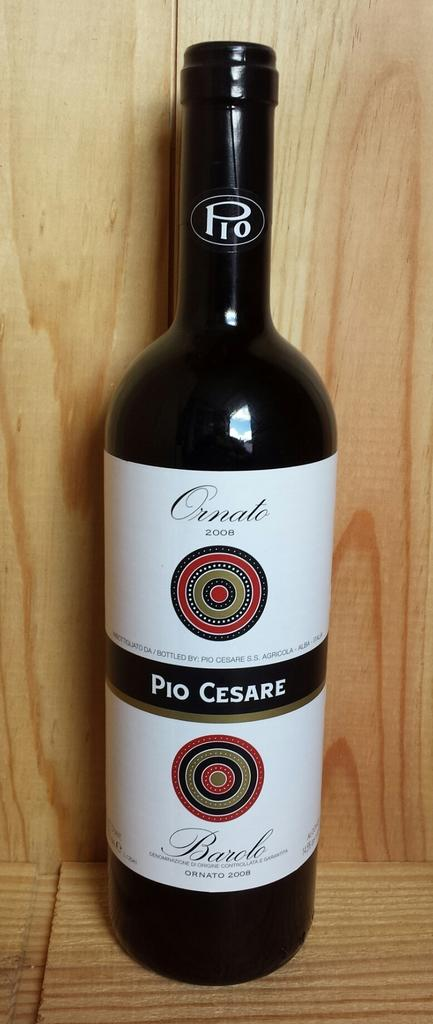<image>
Share a concise interpretation of the image provided. A bottle of Pio Cesare sits on a wooden shelf. 